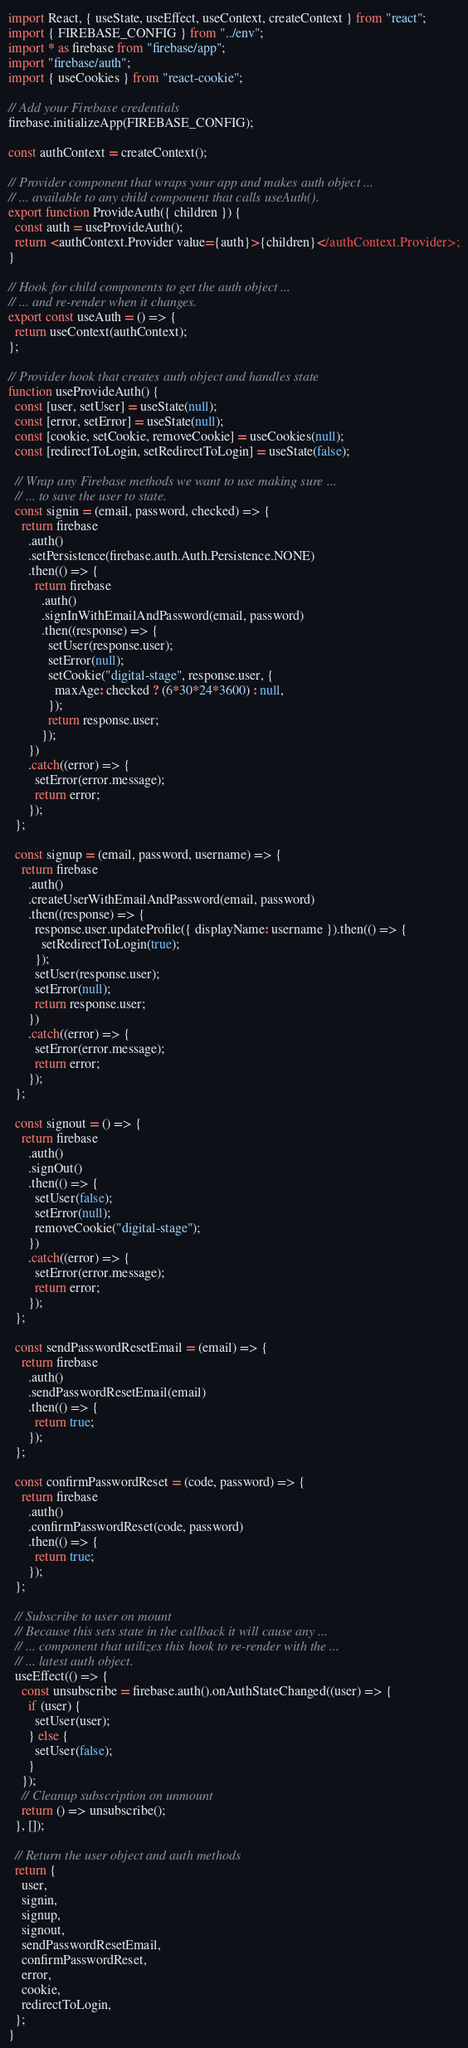<code> <loc_0><loc_0><loc_500><loc_500><_JavaScript_>import React, { useState, useEffect, useContext, createContext } from "react";
import { FIREBASE_CONFIG } from "../env";
import * as firebase from "firebase/app";
import "firebase/auth";
import { useCookies } from "react-cookie";

// Add your Firebase credentials
firebase.initializeApp(FIREBASE_CONFIG);

const authContext = createContext();

// Provider component that wraps your app and makes auth object ...
// ... available to any child component that calls useAuth().
export function ProvideAuth({ children }) {
  const auth = useProvideAuth();
  return <authContext.Provider value={auth}>{children}</authContext.Provider>;
}

// Hook for child components to get the auth object ...
// ... and re-render when it changes.
export const useAuth = () => {
  return useContext(authContext);
};

// Provider hook that creates auth object and handles state
function useProvideAuth() {
  const [user, setUser] = useState(null);
  const [error, setError] = useState(null);
  const [cookie, setCookie, removeCookie] = useCookies(null);
  const [redirectToLogin, setRedirectToLogin] = useState(false);

  // Wrap any Firebase methods we want to use making sure ...
  // ... to save the user to state.
  const signin = (email, password, checked) => {
    return firebase
      .auth()
      .setPersistence(firebase.auth.Auth.Persistence.NONE)
      .then(() => {
        return firebase
          .auth()
          .signInWithEmailAndPassword(email, password)
          .then((response) => {
            setUser(response.user);
            setError(null);
            setCookie("digital-stage", response.user, {
              maxAge: checked ? (6*30*24*3600) : null,
            });
            return response.user;
          });
      })
      .catch((error) => {
        setError(error.message);
        return error;
      });
  };

  const signup = (email, password, username) => {
    return firebase
      .auth()
      .createUserWithEmailAndPassword(email, password)
      .then((response) => {
        response.user.updateProfile({ displayName: username }).then(() => {
          setRedirectToLogin(true);
        });
        setUser(response.user);
        setError(null);
        return response.user;
      })
      .catch((error) => {
        setError(error.message);
        return error;
      });
  };

  const signout = () => {
    return firebase
      .auth()
      .signOut()
      .then(() => {
        setUser(false);
        setError(null);
        removeCookie("digital-stage");
      })
      .catch((error) => {
        setError(error.message);
        return error;
      });
  };

  const sendPasswordResetEmail = (email) => {
    return firebase
      .auth()
      .sendPasswordResetEmail(email)
      .then(() => {
        return true;
      });
  };

  const confirmPasswordReset = (code, password) => {
    return firebase
      .auth()
      .confirmPasswordReset(code, password)
      .then(() => {
        return true;
      });
  };

  // Subscribe to user on mount
  // Because this sets state in the callback it will cause any ...
  // ... component that utilizes this hook to re-render with the ...
  // ... latest auth object.
  useEffect(() => {
    const unsubscribe = firebase.auth().onAuthStateChanged((user) => {
      if (user) {
        setUser(user);
      } else {
        setUser(false);
      }
    });
    // Cleanup subscription on unmount
    return () => unsubscribe();
  }, []);

  // Return the user object and auth methods
  return {
    user,
    signin,
    signup,
    signout,
    sendPasswordResetEmail,
    confirmPasswordReset,
    error,
    cookie,
    redirectToLogin,
  };
}
</code> 